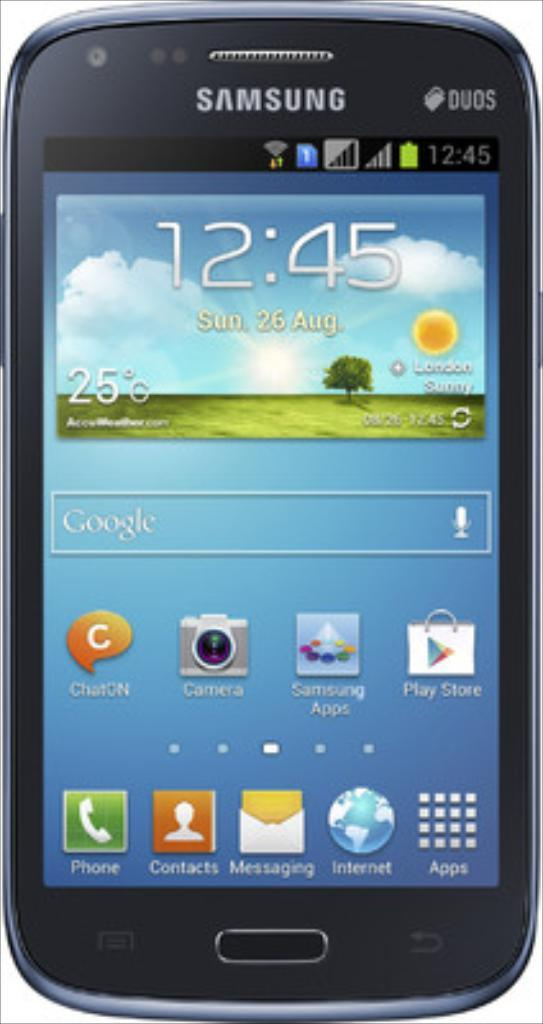<image>
Summarize the visual content of the image. A samsung smart phone open to its home page. 